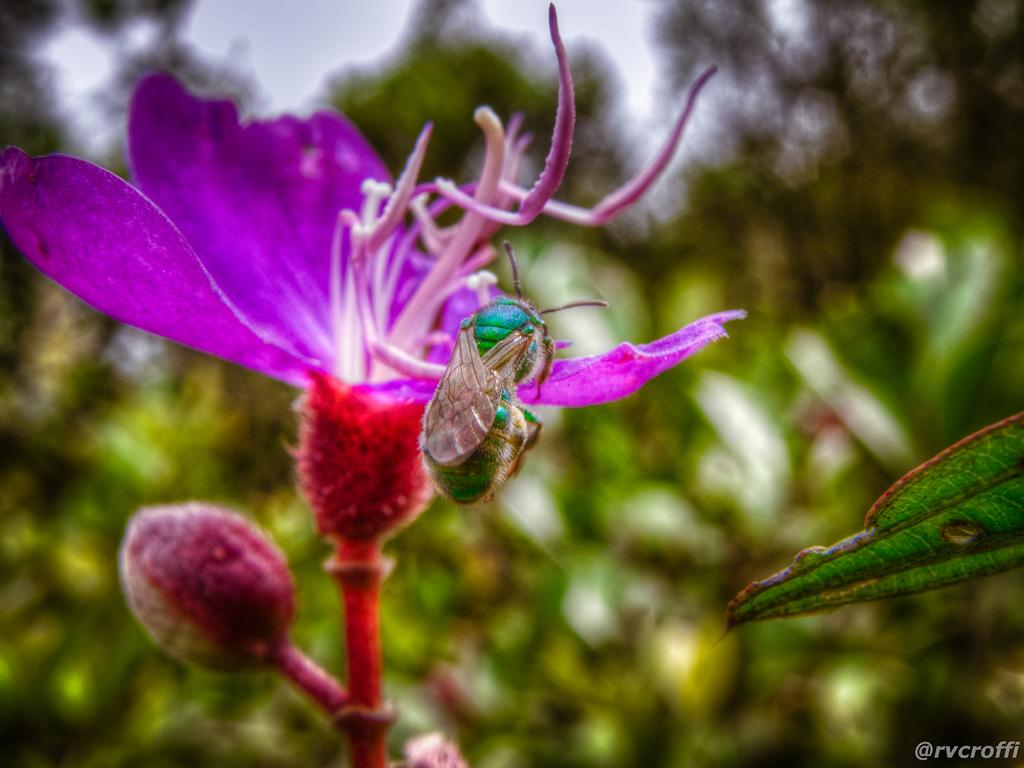What is the main subject of the image? There is a flower in the image. Can you describe the colors of the flower? The flower has purple and red colors. Is there anything else present on the flower? Yes, there is an insect on the flower. What can be seen in the bottom right corner of the image? There is a watermark in the right bottom corner of the image. How would you describe the background of the image? The background of the image is blurred. What type of car can be seen in the background of the image? There is no car present in the image; the background is blurred. Are there any giants visible in the image? There are no giants present in the image; it features a flower with an insect. 